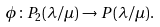Convert formula to latex. <formula><loc_0><loc_0><loc_500><loc_500>\phi \colon P _ { 2 } ( \lambda / \mu ) \to P ( \lambda / \mu ) .</formula> 